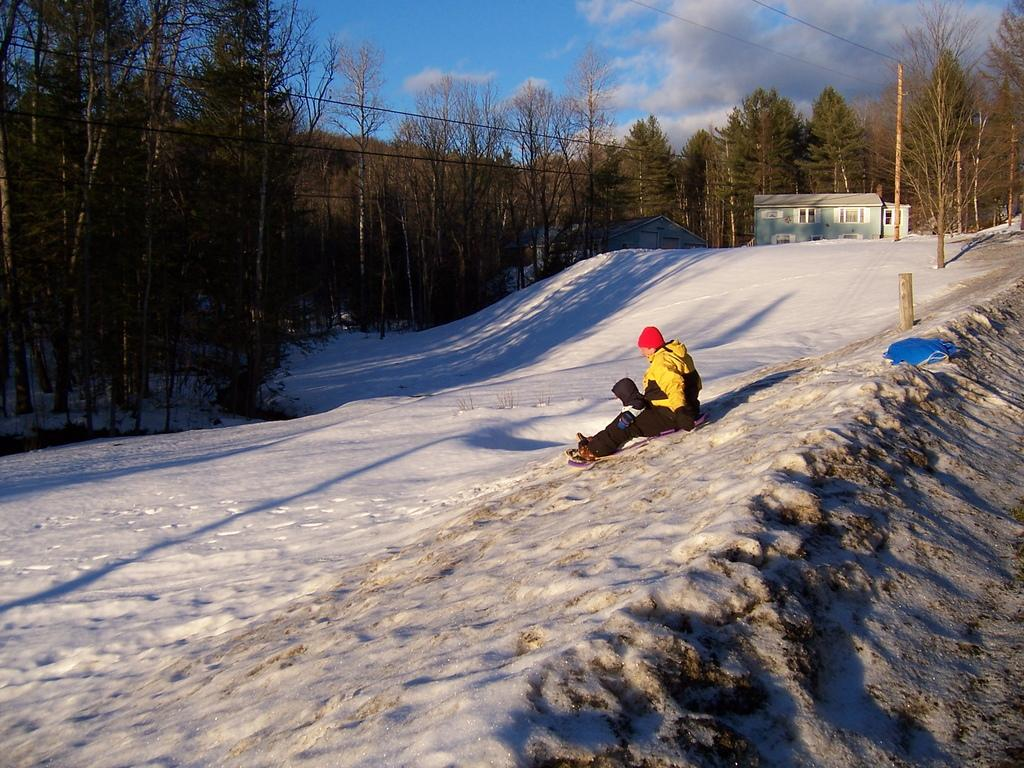What is the person in the image doing? The person is sitting on the snow. What can be seen in the background of the image? There are poles with wires, a group of trees, and a house with a roof and windows in the image. What is the condition of the sky in the image? The sky is visible and appears cloudy in the image. What type of thunder can be heard in the image? There is no thunder present in the image; it only shows a person sitting on the snow and the surrounding environment. Can you tell me the name of the person's brother in the image? There is no information about the person's brother in the image, as it only shows the person sitting on the snow and the surrounding environment. 